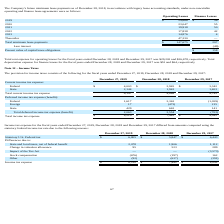From Chefs Wharehouse's financial document, What is the Statutory U.S. Federal tax for 2019, 2018 and 2017 respectively? The document contains multiple relevant values: $6,805, $5,847, $6,443. From the document: "Statutory U.S. Federal tax $ 6,805 $ 5,847 $ 6,443 Statutory U.S. Federal tax $ 6,805 $ 5,847 $ 6,443 Statutory U.S. Federal tax $ 6,805 $ 5,847 $ 6,4..." Also, What is the Income tax expense for 2019, 2018 and 2017 respectively? The document contains multiple relevant values: $8,210, $7,442, $4,042. From the document: "Total income tax expense $ 8,210 $ 7,442 $ 4,042 Total income tax expense $ 8,210 $ 7,442 $ 4,042 Total income tax expense $ 8,210 $ 7,442 $ 4,042..." Also, What is the change in valuation allowance for 2017? According to the financial document, 289. The relevant text states: "Change in valuation allowance 95 523 289..." Additionally, Which year has the highest Statutory U.S. Federal tax? According to the financial document, 2019. The relevant text states: "December 27, 2019 December 28, 2018 December 29, 2017..." Also, can you calculate: What is the change in Statutory U.S. Federal tax between 2018 and 2019? Based on the calculation: 6,805-5,847, the result is 958. This is based on the information: "Statutory U.S. Federal tax $ 6,805 $ 5,847 $ 6,443 Statutory U.S. Federal tax $ 6,805 $ 5,847 $ 6,443..." The key data points involved are: 5,847, 6,805. Also, can you calculate: What is the average Statutory U.S. Federal tax from 2017-2019? To answer this question, I need to perform calculations using the financial data. The calculation is: (6,805+ 5,847+ 6,443)/3, which equals 6365. This is based on the information: "Statutory U.S. Federal tax $ 6,805 $ 5,847 $ 6,443 Statutory U.S. Federal tax $ 6,805 $ 5,847 $ 6,443 Statutory U.S. Federal tax $ 6,805 $ 5,847 $ 6,443..." The key data points involved are: 5,847, 6,443, 6,805. 